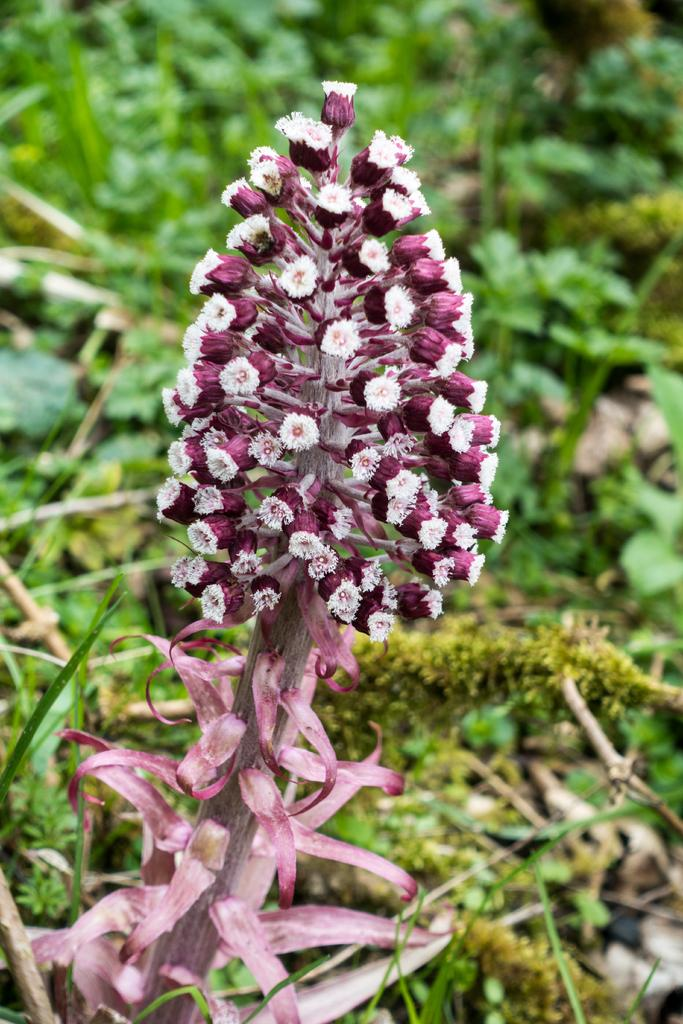What is the main subject in the foreground of the image? There is a flower in the foreground of the image. Is the flower part of a larger plant? Yes, the flower is attached to a plant. What else can be seen in the image besides the flower and its plant? There are other plants visible in the background of the image. What is the mind of the flower doing in the image? Flowers do not have minds, so this question cannot be answered. 